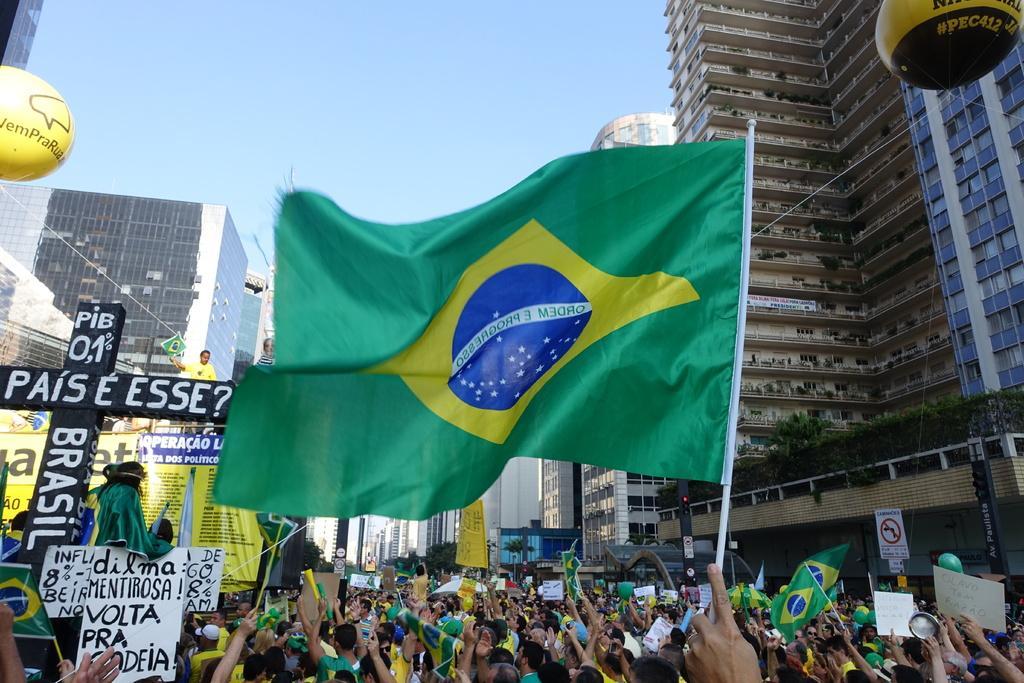Could you give a brief overview of what you see in this image? This is an outside view. At the bottom, I can see a person's hand holding a green color flag and also I can see a crowd of people. Few are holding some boards and banners in their hands. In the background there are many buildings. At the top of the image I can see the sky. On the right and left side of the image there are two balloons on which I can see the text. 